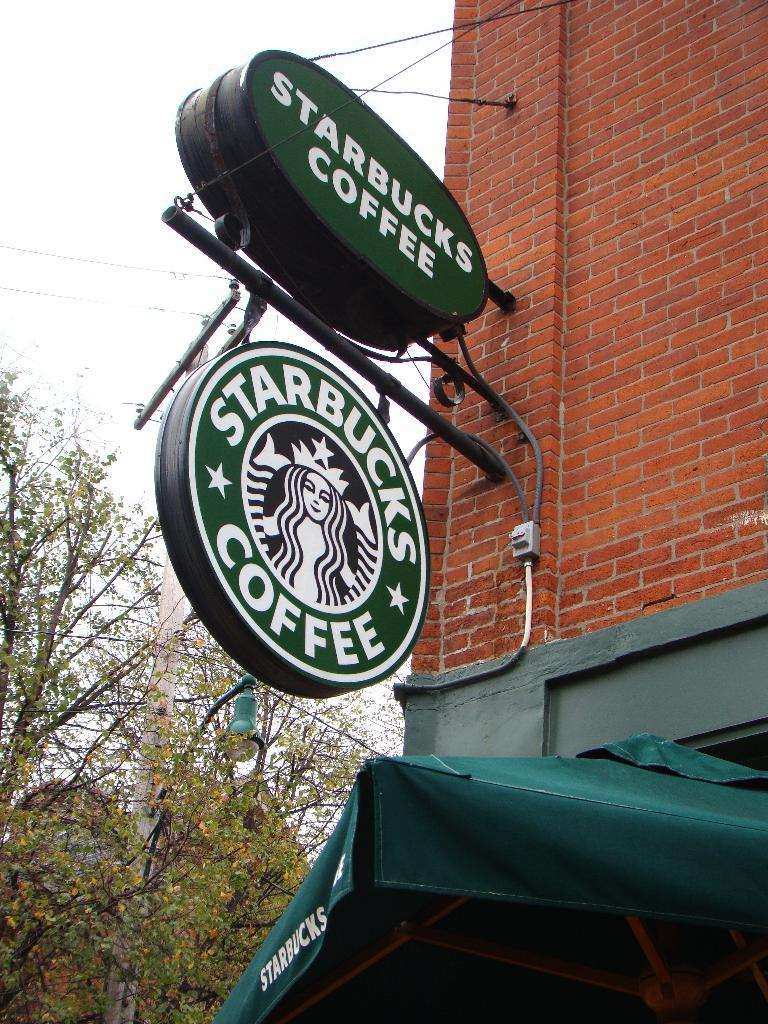What is located in the center of the image? There are advertisement boards in the center of the image. What can be seen in the background of the image? There are trees and a building in the background of the image. How many hands are visible on the advertisement boards in the image? There are no hands visible on the advertisement boards in the image. 